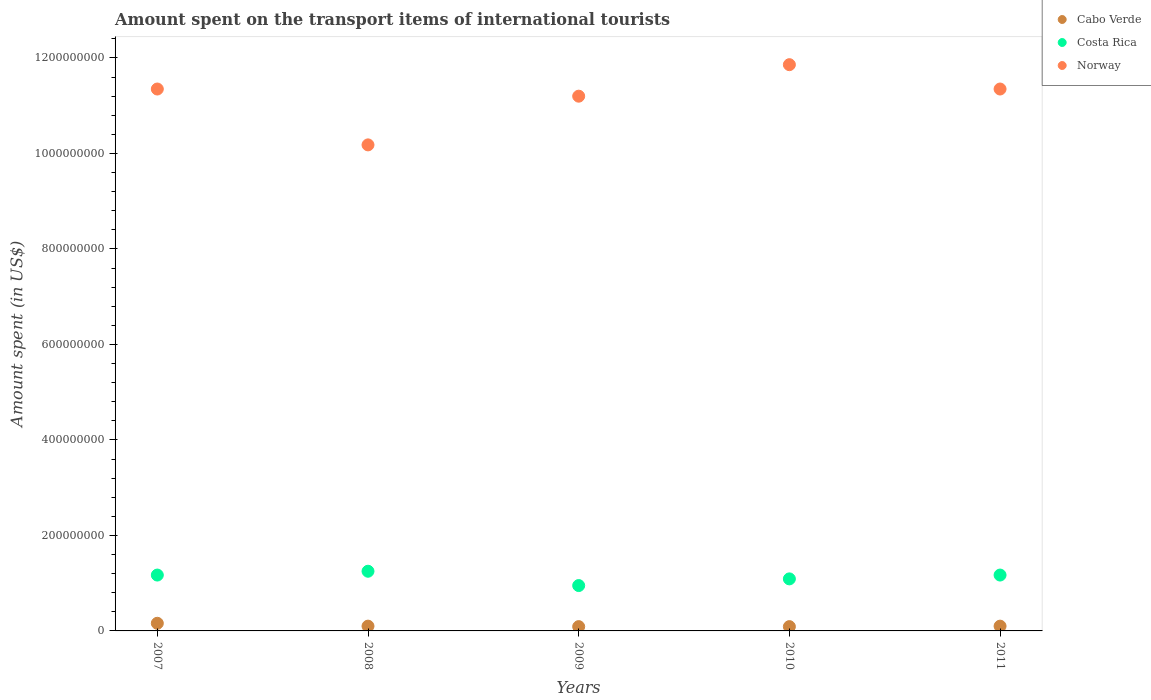Is the number of dotlines equal to the number of legend labels?
Your answer should be compact. Yes. What is the amount spent on the transport items of international tourists in Norway in 2009?
Provide a succinct answer. 1.12e+09. Across all years, what is the maximum amount spent on the transport items of international tourists in Norway?
Ensure brevity in your answer.  1.19e+09. Across all years, what is the minimum amount spent on the transport items of international tourists in Costa Rica?
Offer a very short reply. 9.50e+07. In which year was the amount spent on the transport items of international tourists in Costa Rica minimum?
Make the answer very short. 2009. What is the total amount spent on the transport items of international tourists in Norway in the graph?
Provide a succinct answer. 5.59e+09. What is the difference between the amount spent on the transport items of international tourists in Costa Rica in 2007 and that in 2010?
Your response must be concise. 8.00e+06. What is the difference between the amount spent on the transport items of international tourists in Norway in 2009 and the amount spent on the transport items of international tourists in Cabo Verde in 2010?
Make the answer very short. 1.11e+09. What is the average amount spent on the transport items of international tourists in Costa Rica per year?
Offer a terse response. 1.13e+08. In the year 2009, what is the difference between the amount spent on the transport items of international tourists in Costa Rica and amount spent on the transport items of international tourists in Cabo Verde?
Ensure brevity in your answer.  8.60e+07. In how many years, is the amount spent on the transport items of international tourists in Costa Rica greater than 760000000 US$?
Your answer should be very brief. 0. What is the ratio of the amount spent on the transport items of international tourists in Costa Rica in 2007 to that in 2009?
Your answer should be very brief. 1.23. Is the amount spent on the transport items of international tourists in Cabo Verde in 2008 less than that in 2011?
Your answer should be compact. No. Is the difference between the amount spent on the transport items of international tourists in Costa Rica in 2009 and 2011 greater than the difference between the amount spent on the transport items of international tourists in Cabo Verde in 2009 and 2011?
Ensure brevity in your answer.  No. What is the difference between the highest and the second highest amount spent on the transport items of international tourists in Cabo Verde?
Your response must be concise. 6.00e+06. What is the difference between the highest and the lowest amount spent on the transport items of international tourists in Costa Rica?
Give a very brief answer. 3.00e+07. In how many years, is the amount spent on the transport items of international tourists in Cabo Verde greater than the average amount spent on the transport items of international tourists in Cabo Verde taken over all years?
Make the answer very short. 1. Does the amount spent on the transport items of international tourists in Costa Rica monotonically increase over the years?
Provide a succinct answer. No. Is the amount spent on the transport items of international tourists in Costa Rica strictly less than the amount spent on the transport items of international tourists in Norway over the years?
Your response must be concise. Yes. Does the graph contain grids?
Keep it short and to the point. No. Where does the legend appear in the graph?
Offer a terse response. Top right. How many legend labels are there?
Offer a very short reply. 3. How are the legend labels stacked?
Your response must be concise. Vertical. What is the title of the graph?
Your answer should be compact. Amount spent on the transport items of international tourists. What is the label or title of the Y-axis?
Provide a short and direct response. Amount spent (in US$). What is the Amount spent (in US$) in Cabo Verde in 2007?
Keep it short and to the point. 1.60e+07. What is the Amount spent (in US$) of Costa Rica in 2007?
Keep it short and to the point. 1.17e+08. What is the Amount spent (in US$) in Norway in 2007?
Ensure brevity in your answer.  1.14e+09. What is the Amount spent (in US$) of Cabo Verde in 2008?
Ensure brevity in your answer.  1.00e+07. What is the Amount spent (in US$) in Costa Rica in 2008?
Your response must be concise. 1.25e+08. What is the Amount spent (in US$) of Norway in 2008?
Your answer should be compact. 1.02e+09. What is the Amount spent (in US$) of Cabo Verde in 2009?
Give a very brief answer. 9.00e+06. What is the Amount spent (in US$) in Costa Rica in 2009?
Keep it short and to the point. 9.50e+07. What is the Amount spent (in US$) in Norway in 2009?
Your answer should be compact. 1.12e+09. What is the Amount spent (in US$) in Cabo Verde in 2010?
Provide a short and direct response. 9.00e+06. What is the Amount spent (in US$) in Costa Rica in 2010?
Your answer should be very brief. 1.09e+08. What is the Amount spent (in US$) in Norway in 2010?
Ensure brevity in your answer.  1.19e+09. What is the Amount spent (in US$) in Cabo Verde in 2011?
Provide a succinct answer. 1.00e+07. What is the Amount spent (in US$) of Costa Rica in 2011?
Make the answer very short. 1.17e+08. What is the Amount spent (in US$) of Norway in 2011?
Your answer should be very brief. 1.14e+09. Across all years, what is the maximum Amount spent (in US$) in Cabo Verde?
Your answer should be very brief. 1.60e+07. Across all years, what is the maximum Amount spent (in US$) of Costa Rica?
Your response must be concise. 1.25e+08. Across all years, what is the maximum Amount spent (in US$) in Norway?
Give a very brief answer. 1.19e+09. Across all years, what is the minimum Amount spent (in US$) of Cabo Verde?
Your answer should be compact. 9.00e+06. Across all years, what is the minimum Amount spent (in US$) in Costa Rica?
Give a very brief answer. 9.50e+07. Across all years, what is the minimum Amount spent (in US$) of Norway?
Offer a very short reply. 1.02e+09. What is the total Amount spent (in US$) of Cabo Verde in the graph?
Keep it short and to the point. 5.40e+07. What is the total Amount spent (in US$) of Costa Rica in the graph?
Keep it short and to the point. 5.63e+08. What is the total Amount spent (in US$) in Norway in the graph?
Provide a short and direct response. 5.59e+09. What is the difference between the Amount spent (in US$) of Cabo Verde in 2007 and that in 2008?
Your response must be concise. 6.00e+06. What is the difference between the Amount spent (in US$) in Costa Rica in 2007 and that in 2008?
Make the answer very short. -8.00e+06. What is the difference between the Amount spent (in US$) in Norway in 2007 and that in 2008?
Your answer should be compact. 1.17e+08. What is the difference between the Amount spent (in US$) in Cabo Verde in 2007 and that in 2009?
Your answer should be very brief. 7.00e+06. What is the difference between the Amount spent (in US$) of Costa Rica in 2007 and that in 2009?
Give a very brief answer. 2.20e+07. What is the difference between the Amount spent (in US$) in Norway in 2007 and that in 2009?
Keep it short and to the point. 1.50e+07. What is the difference between the Amount spent (in US$) of Norway in 2007 and that in 2010?
Your answer should be compact. -5.10e+07. What is the difference between the Amount spent (in US$) of Cabo Verde in 2007 and that in 2011?
Provide a short and direct response. 6.00e+06. What is the difference between the Amount spent (in US$) in Norway in 2007 and that in 2011?
Offer a very short reply. 0. What is the difference between the Amount spent (in US$) in Costa Rica in 2008 and that in 2009?
Your response must be concise. 3.00e+07. What is the difference between the Amount spent (in US$) in Norway in 2008 and that in 2009?
Your answer should be very brief. -1.02e+08. What is the difference between the Amount spent (in US$) in Costa Rica in 2008 and that in 2010?
Offer a very short reply. 1.60e+07. What is the difference between the Amount spent (in US$) of Norway in 2008 and that in 2010?
Offer a terse response. -1.68e+08. What is the difference between the Amount spent (in US$) in Cabo Verde in 2008 and that in 2011?
Give a very brief answer. 0. What is the difference between the Amount spent (in US$) of Costa Rica in 2008 and that in 2011?
Provide a succinct answer. 8.00e+06. What is the difference between the Amount spent (in US$) in Norway in 2008 and that in 2011?
Your answer should be very brief. -1.17e+08. What is the difference between the Amount spent (in US$) in Cabo Verde in 2009 and that in 2010?
Ensure brevity in your answer.  0. What is the difference between the Amount spent (in US$) of Costa Rica in 2009 and that in 2010?
Your answer should be very brief. -1.40e+07. What is the difference between the Amount spent (in US$) in Norway in 2009 and that in 2010?
Keep it short and to the point. -6.60e+07. What is the difference between the Amount spent (in US$) in Costa Rica in 2009 and that in 2011?
Provide a short and direct response. -2.20e+07. What is the difference between the Amount spent (in US$) in Norway in 2009 and that in 2011?
Provide a short and direct response. -1.50e+07. What is the difference between the Amount spent (in US$) of Costa Rica in 2010 and that in 2011?
Give a very brief answer. -8.00e+06. What is the difference between the Amount spent (in US$) in Norway in 2010 and that in 2011?
Your answer should be very brief. 5.10e+07. What is the difference between the Amount spent (in US$) in Cabo Verde in 2007 and the Amount spent (in US$) in Costa Rica in 2008?
Make the answer very short. -1.09e+08. What is the difference between the Amount spent (in US$) in Cabo Verde in 2007 and the Amount spent (in US$) in Norway in 2008?
Provide a succinct answer. -1.00e+09. What is the difference between the Amount spent (in US$) in Costa Rica in 2007 and the Amount spent (in US$) in Norway in 2008?
Make the answer very short. -9.01e+08. What is the difference between the Amount spent (in US$) of Cabo Verde in 2007 and the Amount spent (in US$) of Costa Rica in 2009?
Keep it short and to the point. -7.90e+07. What is the difference between the Amount spent (in US$) in Cabo Verde in 2007 and the Amount spent (in US$) in Norway in 2009?
Your answer should be very brief. -1.10e+09. What is the difference between the Amount spent (in US$) of Costa Rica in 2007 and the Amount spent (in US$) of Norway in 2009?
Ensure brevity in your answer.  -1.00e+09. What is the difference between the Amount spent (in US$) in Cabo Verde in 2007 and the Amount spent (in US$) in Costa Rica in 2010?
Make the answer very short. -9.30e+07. What is the difference between the Amount spent (in US$) in Cabo Verde in 2007 and the Amount spent (in US$) in Norway in 2010?
Offer a terse response. -1.17e+09. What is the difference between the Amount spent (in US$) of Costa Rica in 2007 and the Amount spent (in US$) of Norway in 2010?
Your answer should be compact. -1.07e+09. What is the difference between the Amount spent (in US$) of Cabo Verde in 2007 and the Amount spent (in US$) of Costa Rica in 2011?
Make the answer very short. -1.01e+08. What is the difference between the Amount spent (in US$) of Cabo Verde in 2007 and the Amount spent (in US$) of Norway in 2011?
Keep it short and to the point. -1.12e+09. What is the difference between the Amount spent (in US$) in Costa Rica in 2007 and the Amount spent (in US$) in Norway in 2011?
Offer a very short reply. -1.02e+09. What is the difference between the Amount spent (in US$) of Cabo Verde in 2008 and the Amount spent (in US$) of Costa Rica in 2009?
Your response must be concise. -8.50e+07. What is the difference between the Amount spent (in US$) of Cabo Verde in 2008 and the Amount spent (in US$) of Norway in 2009?
Your answer should be compact. -1.11e+09. What is the difference between the Amount spent (in US$) of Costa Rica in 2008 and the Amount spent (in US$) of Norway in 2009?
Offer a very short reply. -9.95e+08. What is the difference between the Amount spent (in US$) of Cabo Verde in 2008 and the Amount spent (in US$) of Costa Rica in 2010?
Offer a terse response. -9.90e+07. What is the difference between the Amount spent (in US$) of Cabo Verde in 2008 and the Amount spent (in US$) of Norway in 2010?
Your answer should be compact. -1.18e+09. What is the difference between the Amount spent (in US$) of Costa Rica in 2008 and the Amount spent (in US$) of Norway in 2010?
Offer a terse response. -1.06e+09. What is the difference between the Amount spent (in US$) of Cabo Verde in 2008 and the Amount spent (in US$) of Costa Rica in 2011?
Offer a terse response. -1.07e+08. What is the difference between the Amount spent (in US$) in Cabo Verde in 2008 and the Amount spent (in US$) in Norway in 2011?
Your response must be concise. -1.12e+09. What is the difference between the Amount spent (in US$) of Costa Rica in 2008 and the Amount spent (in US$) of Norway in 2011?
Give a very brief answer. -1.01e+09. What is the difference between the Amount spent (in US$) of Cabo Verde in 2009 and the Amount spent (in US$) of Costa Rica in 2010?
Make the answer very short. -1.00e+08. What is the difference between the Amount spent (in US$) in Cabo Verde in 2009 and the Amount spent (in US$) in Norway in 2010?
Your response must be concise. -1.18e+09. What is the difference between the Amount spent (in US$) of Costa Rica in 2009 and the Amount spent (in US$) of Norway in 2010?
Offer a very short reply. -1.09e+09. What is the difference between the Amount spent (in US$) of Cabo Verde in 2009 and the Amount spent (in US$) of Costa Rica in 2011?
Provide a succinct answer. -1.08e+08. What is the difference between the Amount spent (in US$) of Cabo Verde in 2009 and the Amount spent (in US$) of Norway in 2011?
Your answer should be very brief. -1.13e+09. What is the difference between the Amount spent (in US$) in Costa Rica in 2009 and the Amount spent (in US$) in Norway in 2011?
Your response must be concise. -1.04e+09. What is the difference between the Amount spent (in US$) of Cabo Verde in 2010 and the Amount spent (in US$) of Costa Rica in 2011?
Your answer should be very brief. -1.08e+08. What is the difference between the Amount spent (in US$) of Cabo Verde in 2010 and the Amount spent (in US$) of Norway in 2011?
Give a very brief answer. -1.13e+09. What is the difference between the Amount spent (in US$) in Costa Rica in 2010 and the Amount spent (in US$) in Norway in 2011?
Provide a short and direct response. -1.03e+09. What is the average Amount spent (in US$) of Cabo Verde per year?
Provide a short and direct response. 1.08e+07. What is the average Amount spent (in US$) in Costa Rica per year?
Offer a terse response. 1.13e+08. What is the average Amount spent (in US$) of Norway per year?
Your response must be concise. 1.12e+09. In the year 2007, what is the difference between the Amount spent (in US$) in Cabo Verde and Amount spent (in US$) in Costa Rica?
Keep it short and to the point. -1.01e+08. In the year 2007, what is the difference between the Amount spent (in US$) in Cabo Verde and Amount spent (in US$) in Norway?
Provide a succinct answer. -1.12e+09. In the year 2007, what is the difference between the Amount spent (in US$) of Costa Rica and Amount spent (in US$) of Norway?
Your answer should be compact. -1.02e+09. In the year 2008, what is the difference between the Amount spent (in US$) in Cabo Verde and Amount spent (in US$) in Costa Rica?
Make the answer very short. -1.15e+08. In the year 2008, what is the difference between the Amount spent (in US$) of Cabo Verde and Amount spent (in US$) of Norway?
Ensure brevity in your answer.  -1.01e+09. In the year 2008, what is the difference between the Amount spent (in US$) of Costa Rica and Amount spent (in US$) of Norway?
Provide a short and direct response. -8.93e+08. In the year 2009, what is the difference between the Amount spent (in US$) in Cabo Verde and Amount spent (in US$) in Costa Rica?
Offer a very short reply. -8.60e+07. In the year 2009, what is the difference between the Amount spent (in US$) in Cabo Verde and Amount spent (in US$) in Norway?
Ensure brevity in your answer.  -1.11e+09. In the year 2009, what is the difference between the Amount spent (in US$) in Costa Rica and Amount spent (in US$) in Norway?
Offer a terse response. -1.02e+09. In the year 2010, what is the difference between the Amount spent (in US$) of Cabo Verde and Amount spent (in US$) of Costa Rica?
Make the answer very short. -1.00e+08. In the year 2010, what is the difference between the Amount spent (in US$) in Cabo Verde and Amount spent (in US$) in Norway?
Ensure brevity in your answer.  -1.18e+09. In the year 2010, what is the difference between the Amount spent (in US$) in Costa Rica and Amount spent (in US$) in Norway?
Make the answer very short. -1.08e+09. In the year 2011, what is the difference between the Amount spent (in US$) in Cabo Verde and Amount spent (in US$) in Costa Rica?
Ensure brevity in your answer.  -1.07e+08. In the year 2011, what is the difference between the Amount spent (in US$) in Cabo Verde and Amount spent (in US$) in Norway?
Your answer should be very brief. -1.12e+09. In the year 2011, what is the difference between the Amount spent (in US$) of Costa Rica and Amount spent (in US$) of Norway?
Your response must be concise. -1.02e+09. What is the ratio of the Amount spent (in US$) of Cabo Verde in 2007 to that in 2008?
Give a very brief answer. 1.6. What is the ratio of the Amount spent (in US$) in Costa Rica in 2007 to that in 2008?
Make the answer very short. 0.94. What is the ratio of the Amount spent (in US$) of Norway in 2007 to that in 2008?
Provide a succinct answer. 1.11. What is the ratio of the Amount spent (in US$) in Cabo Verde in 2007 to that in 2009?
Ensure brevity in your answer.  1.78. What is the ratio of the Amount spent (in US$) in Costa Rica in 2007 to that in 2009?
Your answer should be compact. 1.23. What is the ratio of the Amount spent (in US$) of Norway in 2007 to that in 2009?
Offer a terse response. 1.01. What is the ratio of the Amount spent (in US$) in Cabo Verde in 2007 to that in 2010?
Provide a succinct answer. 1.78. What is the ratio of the Amount spent (in US$) in Costa Rica in 2007 to that in 2010?
Ensure brevity in your answer.  1.07. What is the ratio of the Amount spent (in US$) in Costa Rica in 2007 to that in 2011?
Give a very brief answer. 1. What is the ratio of the Amount spent (in US$) of Cabo Verde in 2008 to that in 2009?
Keep it short and to the point. 1.11. What is the ratio of the Amount spent (in US$) of Costa Rica in 2008 to that in 2009?
Offer a terse response. 1.32. What is the ratio of the Amount spent (in US$) of Norway in 2008 to that in 2009?
Offer a very short reply. 0.91. What is the ratio of the Amount spent (in US$) of Cabo Verde in 2008 to that in 2010?
Offer a terse response. 1.11. What is the ratio of the Amount spent (in US$) of Costa Rica in 2008 to that in 2010?
Offer a terse response. 1.15. What is the ratio of the Amount spent (in US$) of Norway in 2008 to that in 2010?
Offer a terse response. 0.86. What is the ratio of the Amount spent (in US$) of Cabo Verde in 2008 to that in 2011?
Keep it short and to the point. 1. What is the ratio of the Amount spent (in US$) in Costa Rica in 2008 to that in 2011?
Keep it short and to the point. 1.07. What is the ratio of the Amount spent (in US$) in Norway in 2008 to that in 2011?
Give a very brief answer. 0.9. What is the ratio of the Amount spent (in US$) in Costa Rica in 2009 to that in 2010?
Keep it short and to the point. 0.87. What is the ratio of the Amount spent (in US$) in Costa Rica in 2009 to that in 2011?
Provide a succinct answer. 0.81. What is the ratio of the Amount spent (in US$) of Norway in 2009 to that in 2011?
Keep it short and to the point. 0.99. What is the ratio of the Amount spent (in US$) in Cabo Verde in 2010 to that in 2011?
Provide a succinct answer. 0.9. What is the ratio of the Amount spent (in US$) of Costa Rica in 2010 to that in 2011?
Keep it short and to the point. 0.93. What is the ratio of the Amount spent (in US$) in Norway in 2010 to that in 2011?
Provide a succinct answer. 1.04. What is the difference between the highest and the second highest Amount spent (in US$) of Cabo Verde?
Provide a succinct answer. 6.00e+06. What is the difference between the highest and the second highest Amount spent (in US$) in Norway?
Provide a short and direct response. 5.10e+07. What is the difference between the highest and the lowest Amount spent (in US$) of Costa Rica?
Provide a succinct answer. 3.00e+07. What is the difference between the highest and the lowest Amount spent (in US$) in Norway?
Your response must be concise. 1.68e+08. 